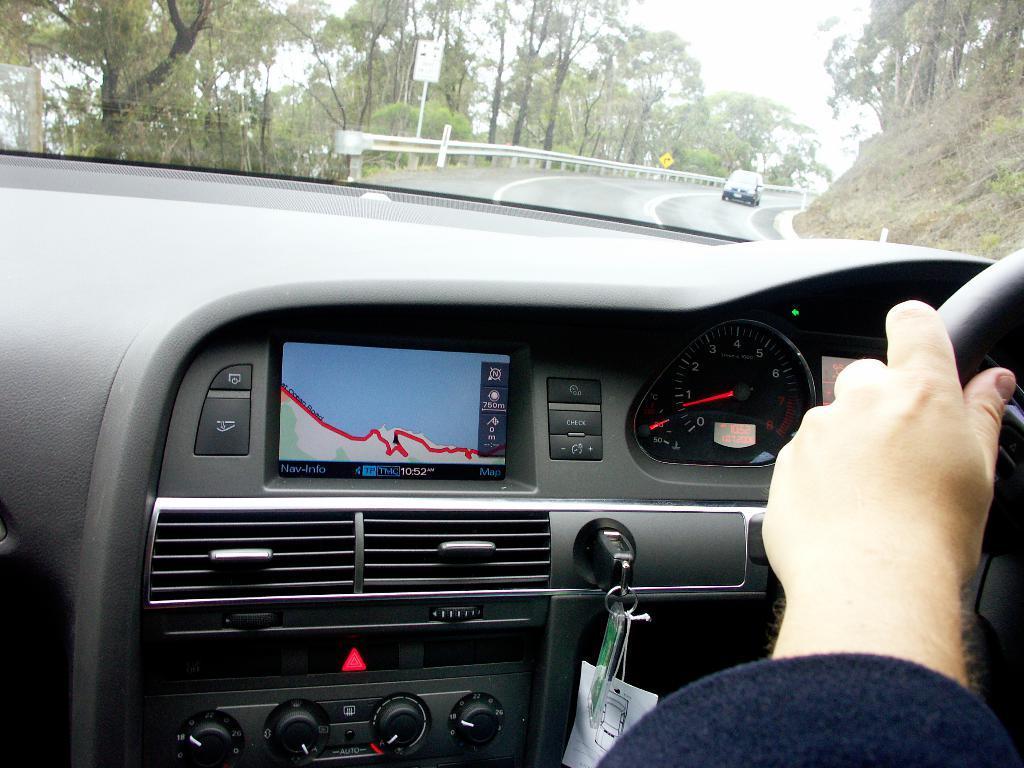In one or two sentences, can you explain what this image depicts? This picture is taken from inside a car, in this picture there is a dashboard of a car is visible, through the glass there is a road, on that there is a car, trees, mountain are visible 